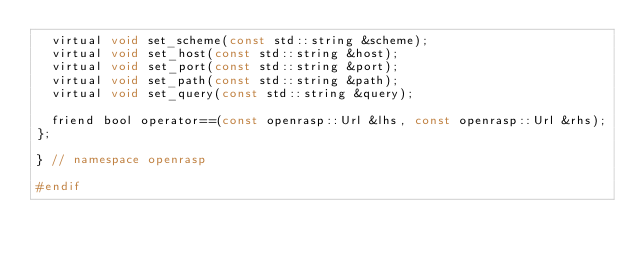Convert code to text. <code><loc_0><loc_0><loc_500><loc_500><_C_>  virtual void set_scheme(const std::string &scheme);
  virtual void set_host(const std::string &host);
  virtual void set_port(const std::string &port);
  virtual void set_path(const std::string &path);
  virtual void set_query(const std::string &query);

  friend bool operator==(const openrasp::Url &lhs, const openrasp::Url &rhs);
};

} // namespace openrasp

#endif
</code> 